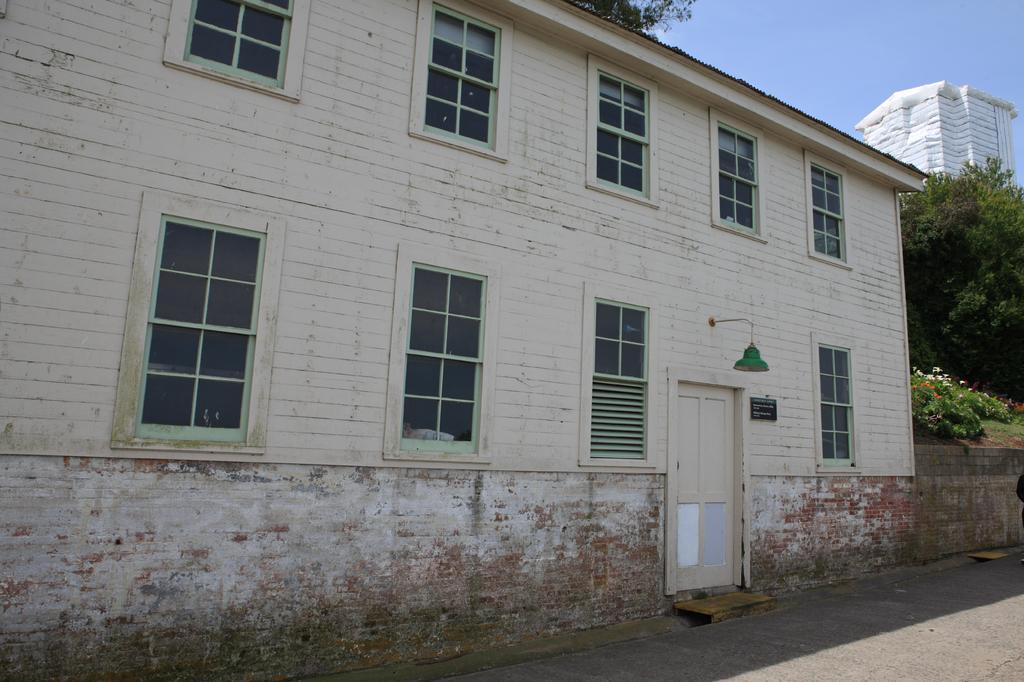Can you describe this image briefly? In this picture I can see a building, road, flowers, trees, and in the background I can see the sky and building. 